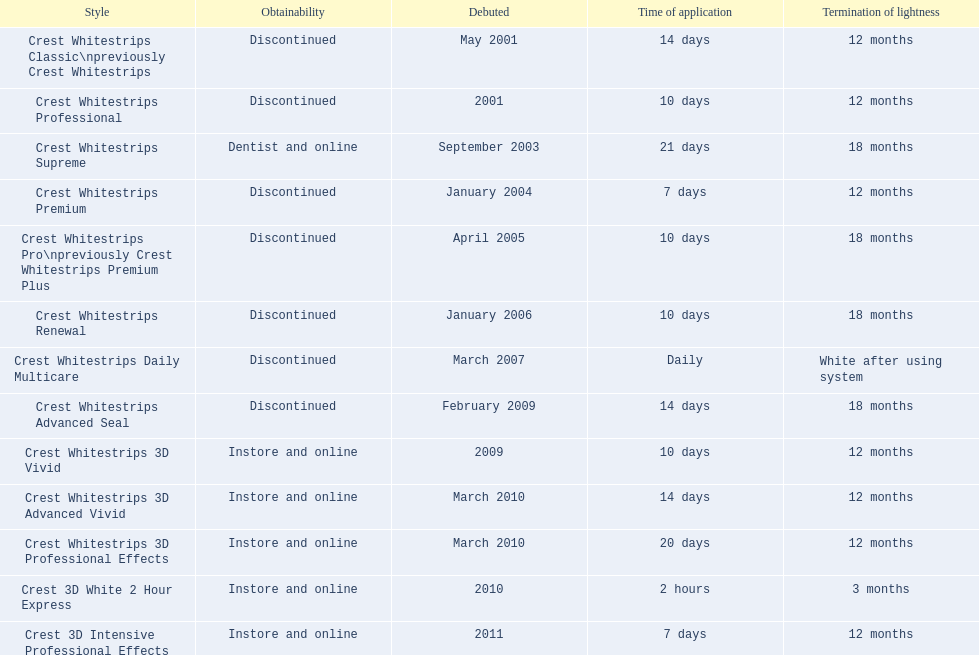Tell me the number of products that give you 12 months of whiteness. 7. 